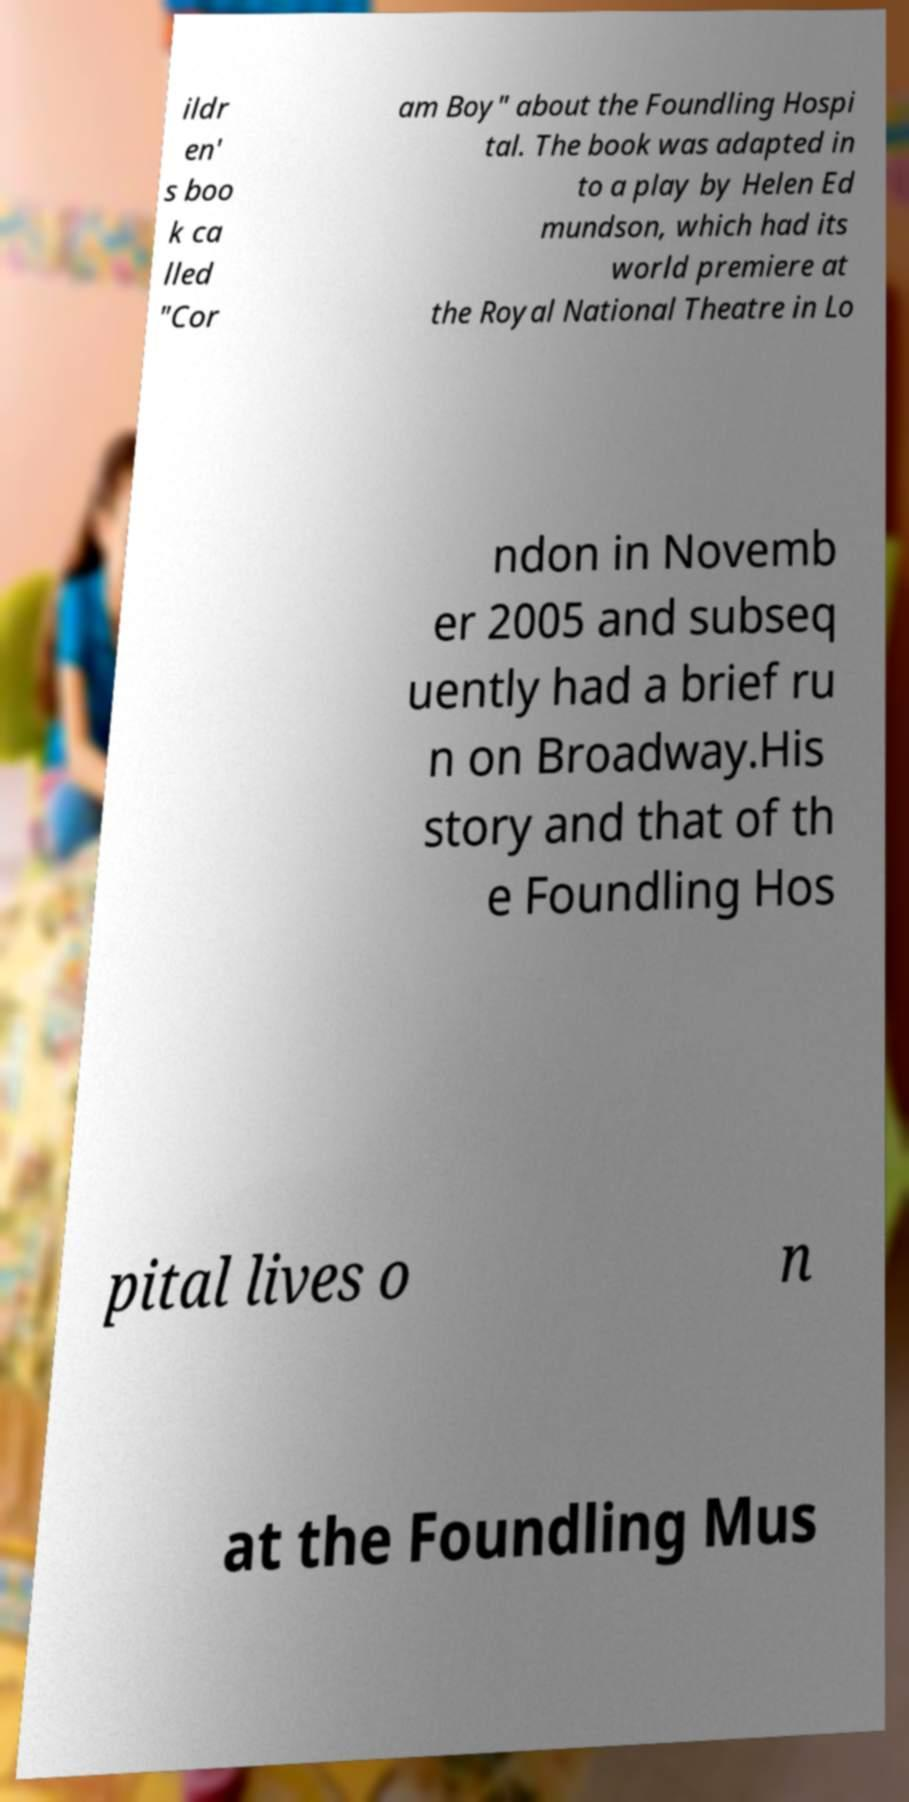Could you extract and type out the text from this image? ildr en' s boo k ca lled "Cor am Boy" about the Foundling Hospi tal. The book was adapted in to a play by Helen Ed mundson, which had its world premiere at the Royal National Theatre in Lo ndon in Novemb er 2005 and subseq uently had a brief ru n on Broadway.His story and that of th e Foundling Hos pital lives o n at the Foundling Mus 